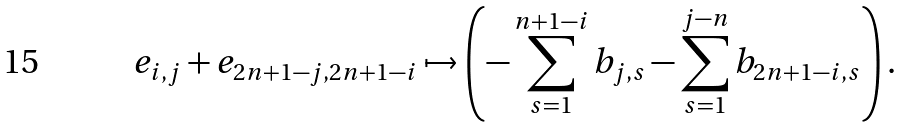<formula> <loc_0><loc_0><loc_500><loc_500>e _ { i , j } + e _ { 2 n + 1 - j , 2 n + 1 - i } \mapsto \left ( - \sum _ { s = 1 } ^ { n + 1 - i } b _ { j , s } - \sum _ { s = 1 } ^ { j - n } b _ { 2 n + 1 - i , s } \right ) .</formula> 